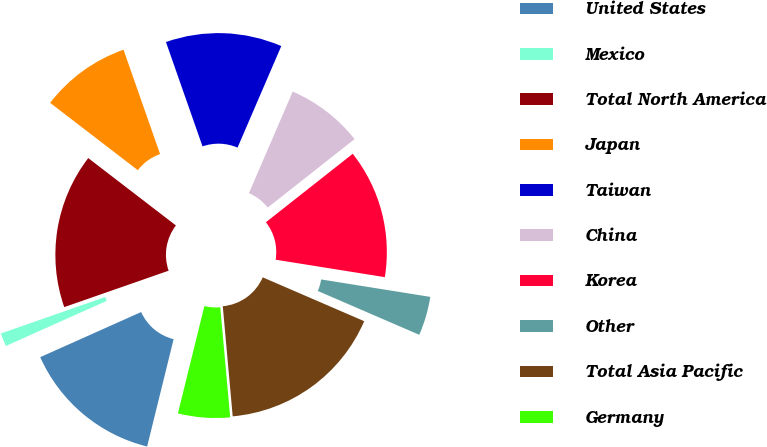Convert chart. <chart><loc_0><loc_0><loc_500><loc_500><pie_chart><fcel>United States<fcel>Mexico<fcel>Total North America<fcel>Japan<fcel>Taiwan<fcel>China<fcel>Korea<fcel>Other<fcel>Total Asia Pacific<fcel>Germany<nl><fcel>14.46%<fcel>1.35%<fcel>15.77%<fcel>9.21%<fcel>11.84%<fcel>7.9%<fcel>13.15%<fcel>3.97%<fcel>17.08%<fcel>5.28%<nl></chart> 